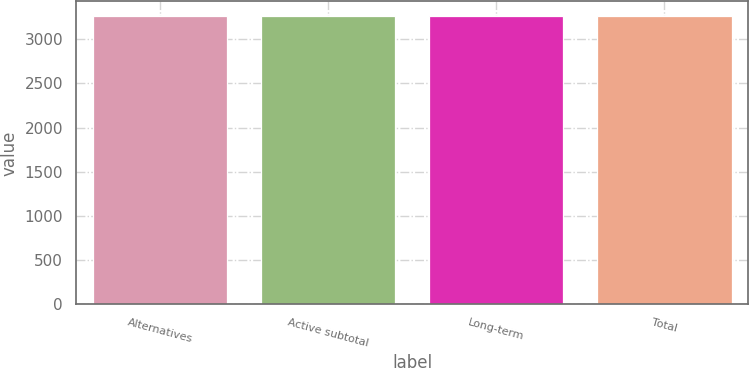Convert chart. <chart><loc_0><loc_0><loc_500><loc_500><bar_chart><fcel>Alternatives<fcel>Active subtotal<fcel>Long-term<fcel>Total<nl><fcel>3264<fcel>3264.1<fcel>3264.2<fcel>3264.3<nl></chart> 